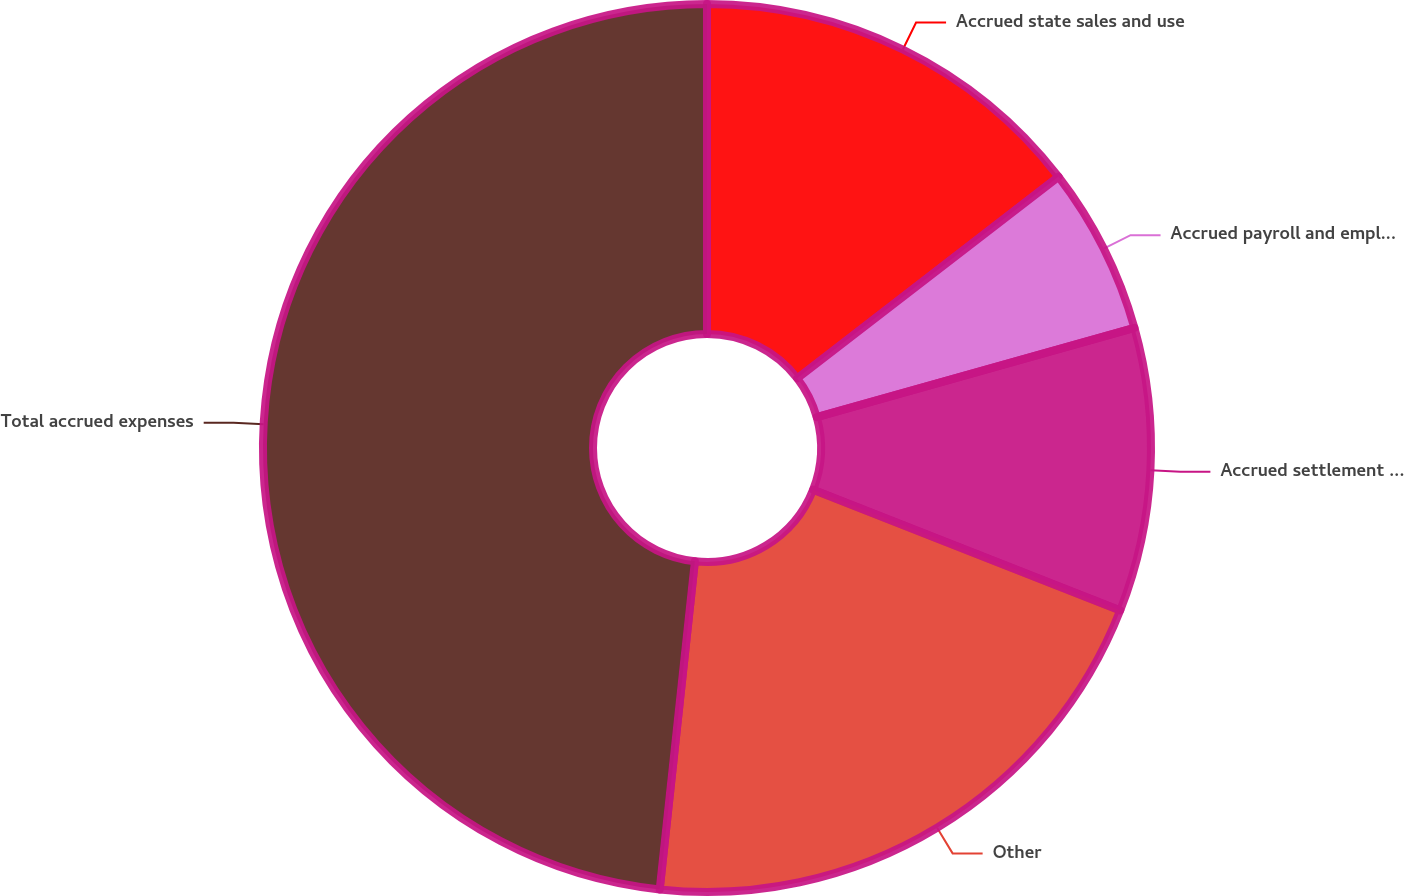Convert chart. <chart><loc_0><loc_0><loc_500><loc_500><pie_chart><fcel>Accrued state sales and use<fcel>Accrued payroll and employee<fcel>Accrued settlement costs<fcel>Other<fcel>Total accrued expenses<nl><fcel>14.54%<fcel>6.1%<fcel>10.32%<fcel>20.74%<fcel>48.3%<nl></chart> 